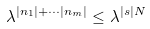<formula> <loc_0><loc_0><loc_500><loc_500>\lambda ^ { | n _ { 1 } | + \cdots | n _ { m } | } \leq \lambda ^ { | s | N }</formula> 